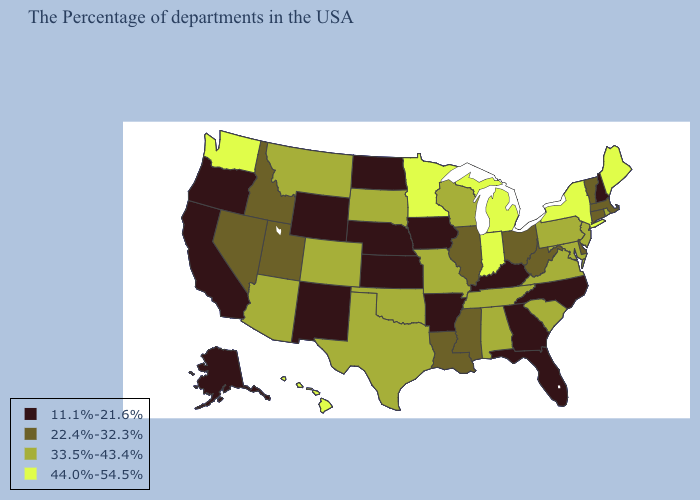What is the value of Kentucky?
Concise answer only. 11.1%-21.6%. What is the value of Alabama?
Short answer required. 33.5%-43.4%. Name the states that have a value in the range 33.5%-43.4%?
Short answer required. Rhode Island, New Jersey, Maryland, Pennsylvania, Virginia, South Carolina, Alabama, Tennessee, Wisconsin, Missouri, Oklahoma, Texas, South Dakota, Colorado, Montana, Arizona. Name the states that have a value in the range 33.5%-43.4%?
Answer briefly. Rhode Island, New Jersey, Maryland, Pennsylvania, Virginia, South Carolina, Alabama, Tennessee, Wisconsin, Missouri, Oklahoma, Texas, South Dakota, Colorado, Montana, Arizona. Name the states that have a value in the range 33.5%-43.4%?
Short answer required. Rhode Island, New Jersey, Maryland, Pennsylvania, Virginia, South Carolina, Alabama, Tennessee, Wisconsin, Missouri, Oklahoma, Texas, South Dakota, Colorado, Montana, Arizona. What is the highest value in the USA?
Quick response, please. 44.0%-54.5%. What is the value of Utah?
Answer briefly. 22.4%-32.3%. Does Iowa have the highest value in the MidWest?
Answer briefly. No. Does the first symbol in the legend represent the smallest category?
Write a very short answer. Yes. Does Illinois have the lowest value in the MidWest?
Keep it brief. No. Which states have the highest value in the USA?
Keep it brief. Maine, New York, Michigan, Indiana, Minnesota, Washington, Hawaii. Name the states that have a value in the range 11.1%-21.6%?
Short answer required. New Hampshire, North Carolina, Florida, Georgia, Kentucky, Arkansas, Iowa, Kansas, Nebraska, North Dakota, Wyoming, New Mexico, California, Oregon, Alaska. Among the states that border Ohio , does Pennsylvania have the lowest value?
Quick response, please. No. 